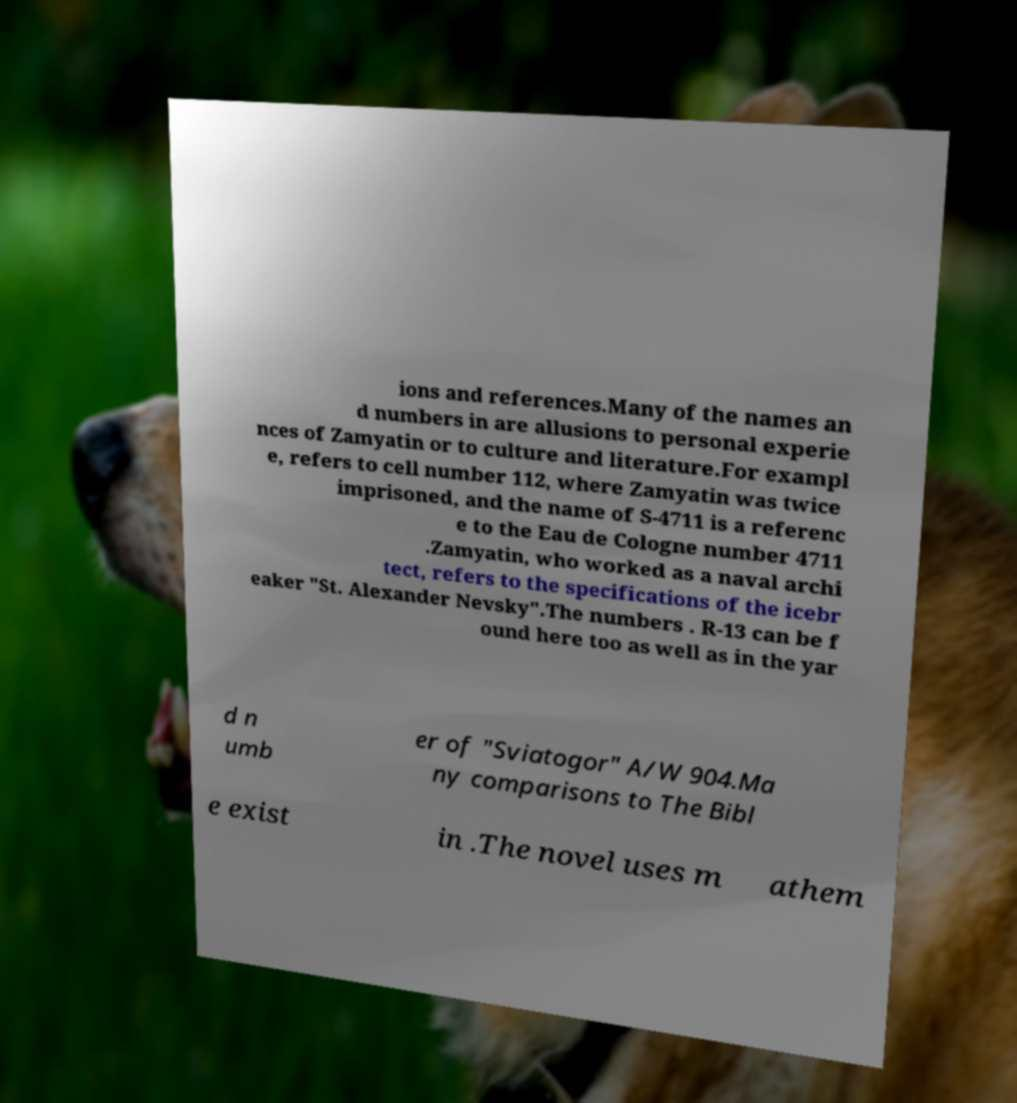Could you assist in decoding the text presented in this image and type it out clearly? ions and references.Many of the names an d numbers in are allusions to personal experie nces of Zamyatin or to culture and literature.For exampl e, refers to cell number 112, where Zamyatin was twice imprisoned, and the name of S-4711 is a referenc e to the Eau de Cologne number 4711 .Zamyatin, who worked as a naval archi tect, refers to the specifications of the icebr eaker "St. Alexander Nevsky".The numbers . R-13 can be f ound here too as well as in the yar d n umb er of "Sviatogor" A/W 904.Ma ny comparisons to The Bibl e exist in .The novel uses m athem 